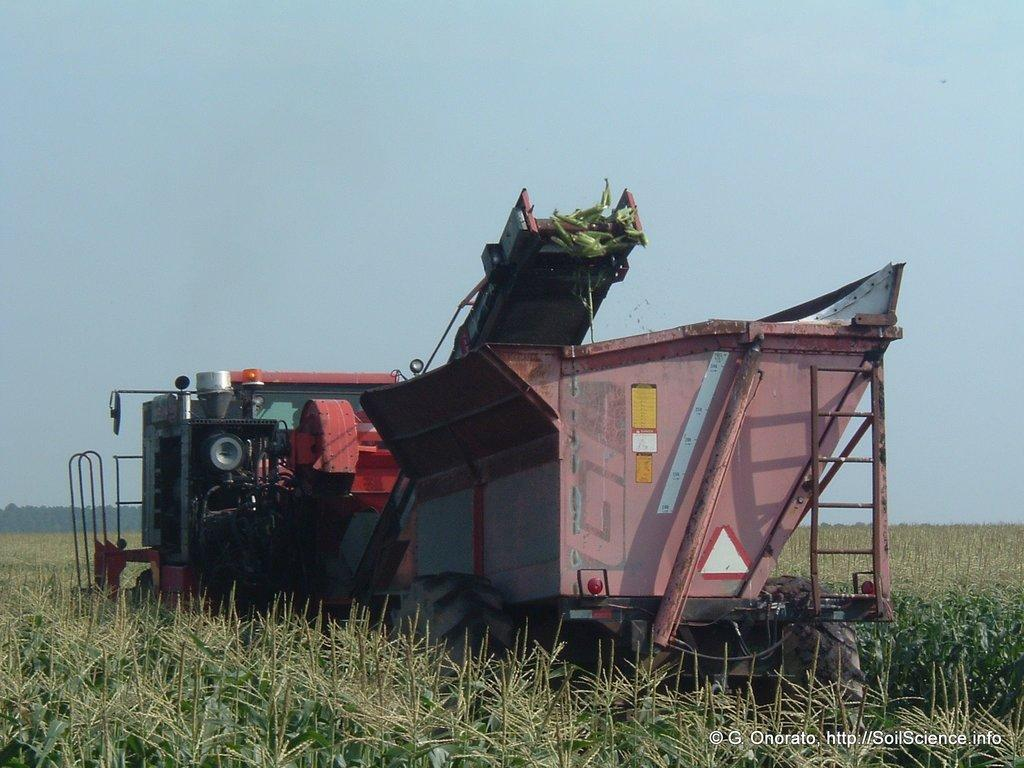What type of objects are located at the bottom of the image? There are many plants at the bottom of the image. What is the main subject in the center of the image? There is a machine at the center of the image. Where can text be found in the image? The text is in the bottom right-hand side of the image. What is visible at the top of the image? The sky is visible at the top of the image. How many houses are visible in the image? There are no houses present in the image. What type of geese can be seen flying in the sky? There are no geese visible in the image; only the sky is visible at the top. 